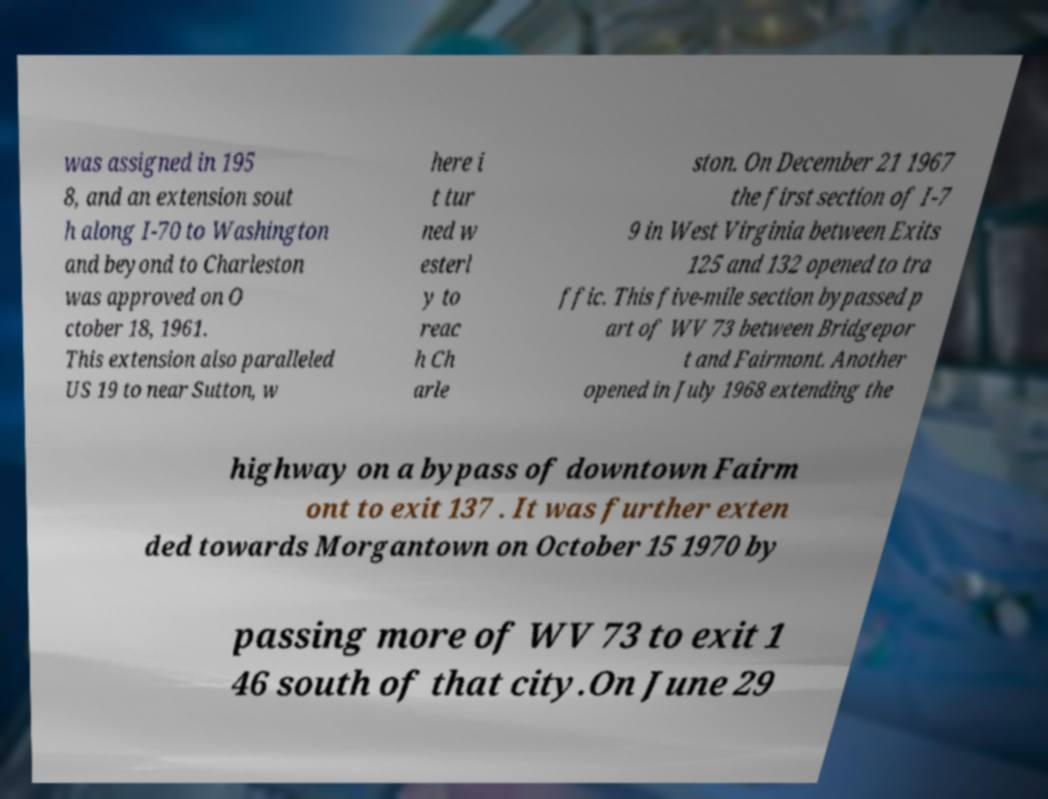I need the written content from this picture converted into text. Can you do that? was assigned in 195 8, and an extension sout h along I-70 to Washington and beyond to Charleston was approved on O ctober 18, 1961. This extension also paralleled US 19 to near Sutton, w here i t tur ned w esterl y to reac h Ch arle ston. On December 21 1967 the first section of I-7 9 in West Virginia between Exits 125 and 132 opened to tra ffic. This five-mile section bypassed p art of WV 73 between Bridgepor t and Fairmont. Another opened in July 1968 extending the highway on a bypass of downtown Fairm ont to exit 137 . It was further exten ded towards Morgantown on October 15 1970 by passing more of WV 73 to exit 1 46 south of that city.On June 29 